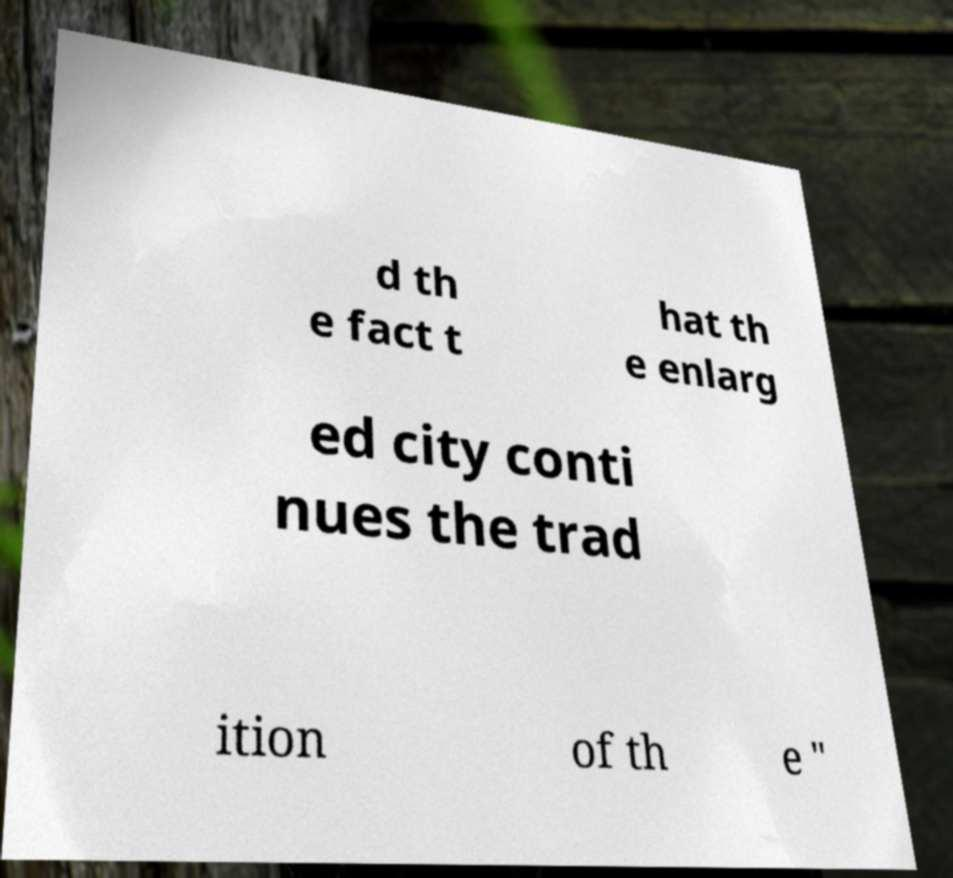Please read and relay the text visible in this image. What does it say? d th e fact t hat th e enlarg ed city conti nues the trad ition of th e " 